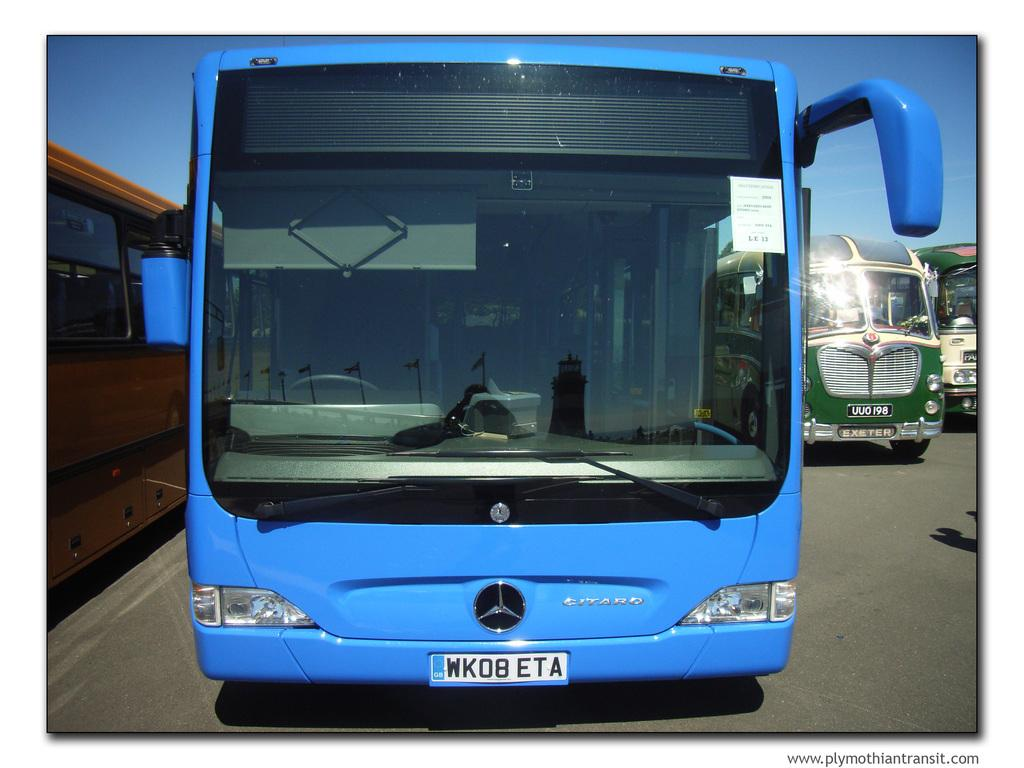<image>
Summarize the visual content of the image. The blue Citaro bus' license plate reads WK08ETA. 